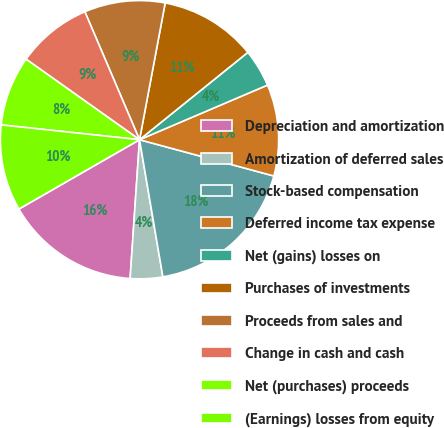Convert chart to OTSL. <chart><loc_0><loc_0><loc_500><loc_500><pie_chart><fcel>Depreciation and amortization<fcel>Amortization of deferred sales<fcel>Stock-based compensation<fcel>Deferred income tax expense<fcel>Net (gains) losses on<fcel>Purchases of investments<fcel>Proceeds from sales and<fcel>Change in cash and cash<fcel>Net (purchases) proceeds<fcel>(Earnings) losses from equity<nl><fcel>15.62%<fcel>3.76%<fcel>18.12%<fcel>10.62%<fcel>4.38%<fcel>11.25%<fcel>9.38%<fcel>8.75%<fcel>8.13%<fcel>10.0%<nl></chart> 